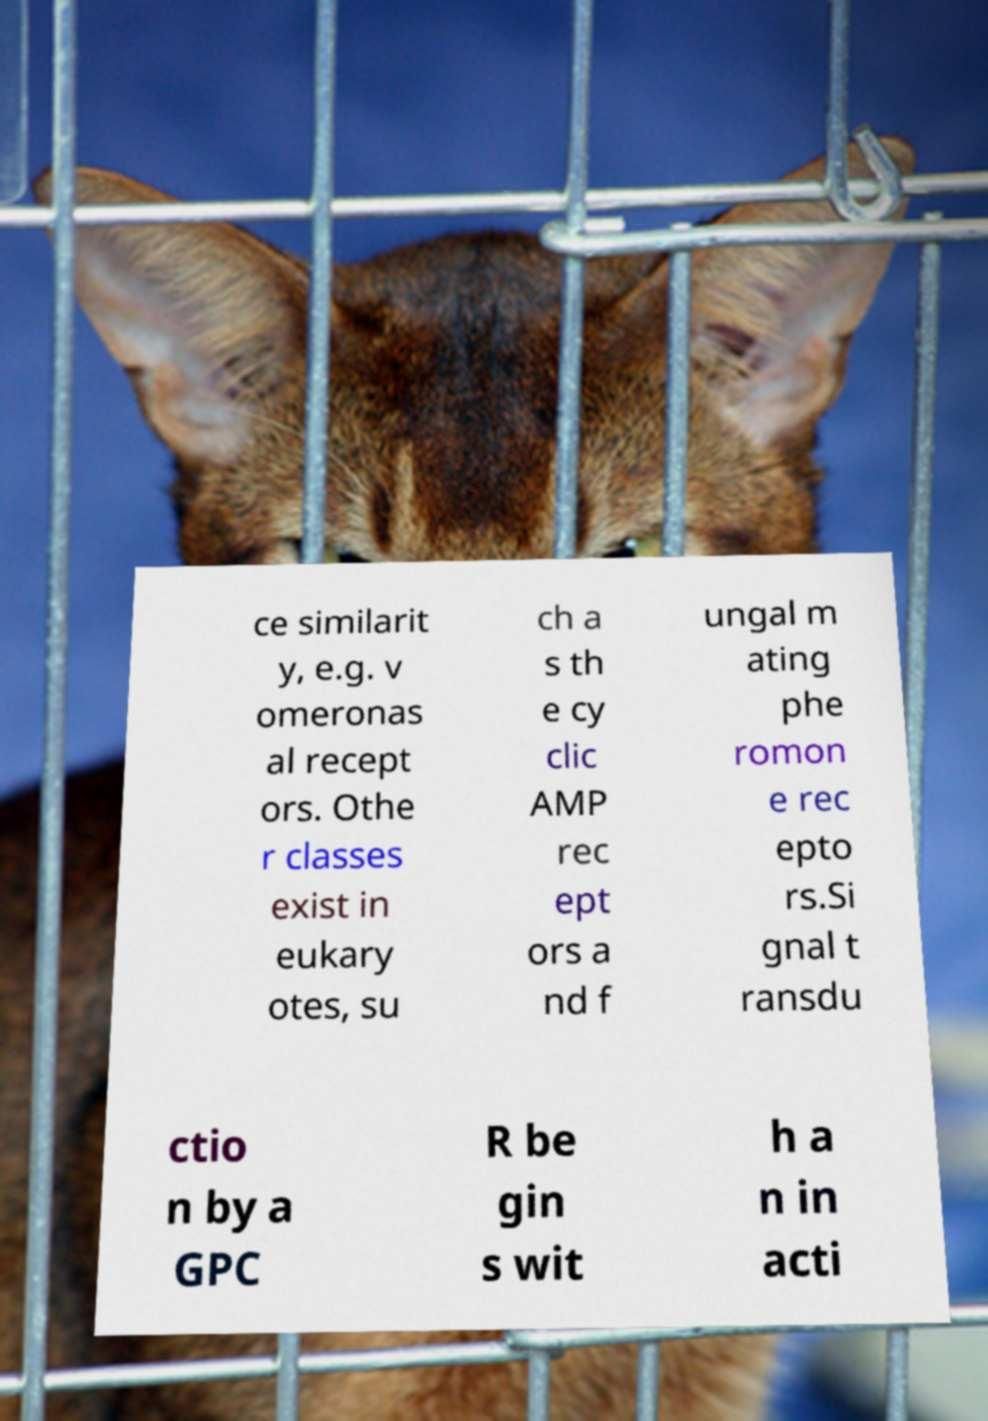I need the written content from this picture converted into text. Can you do that? ce similarit y, e.g. v omeronas al recept ors. Othe r classes exist in eukary otes, su ch a s th e cy clic AMP rec ept ors a nd f ungal m ating phe romon e rec epto rs.Si gnal t ransdu ctio n by a GPC R be gin s wit h a n in acti 